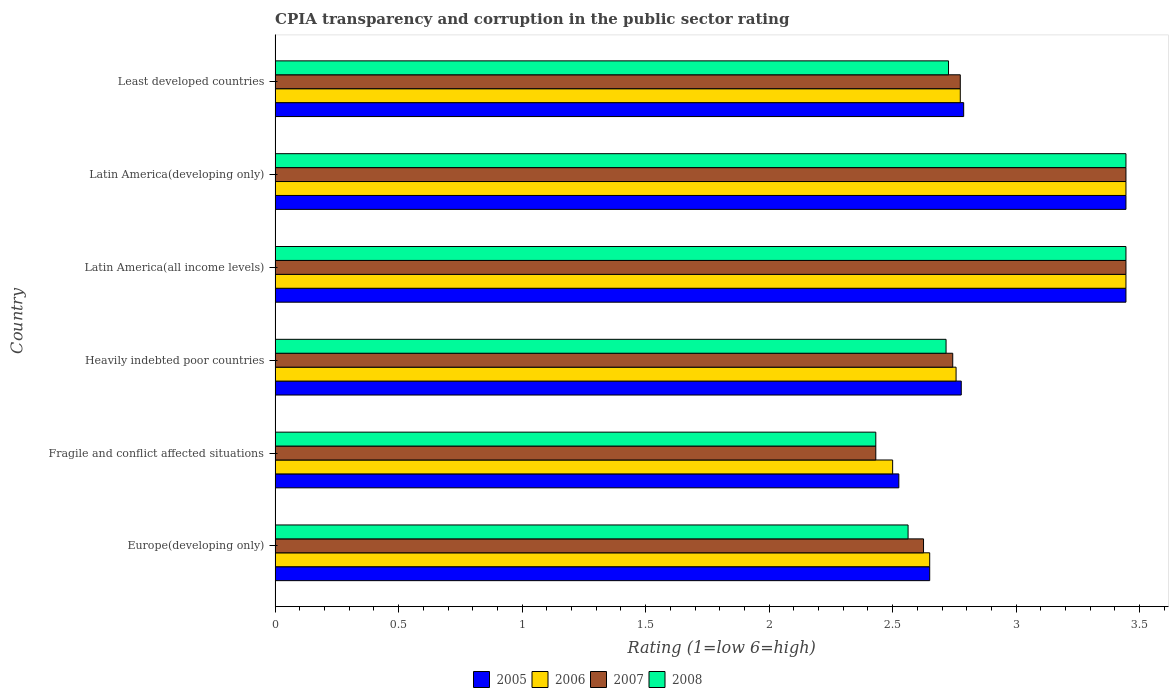How many different coloured bars are there?
Provide a short and direct response. 4. How many bars are there on the 3rd tick from the top?
Offer a terse response. 4. How many bars are there on the 2nd tick from the bottom?
Your answer should be compact. 4. What is the label of the 6th group of bars from the top?
Your answer should be compact. Europe(developing only). What is the CPIA rating in 2008 in Latin America(all income levels)?
Provide a succinct answer. 3.44. Across all countries, what is the maximum CPIA rating in 2005?
Provide a succinct answer. 3.44. Across all countries, what is the minimum CPIA rating in 2007?
Your answer should be compact. 2.43. In which country was the CPIA rating in 2006 maximum?
Your answer should be very brief. Latin America(all income levels). In which country was the CPIA rating in 2008 minimum?
Ensure brevity in your answer.  Fragile and conflict affected situations. What is the total CPIA rating in 2008 in the graph?
Give a very brief answer. 17.33. What is the difference between the CPIA rating in 2006 in Europe(developing only) and that in Heavily indebted poor countries?
Your answer should be very brief. -0.11. What is the difference between the CPIA rating in 2008 in Fragile and conflict affected situations and the CPIA rating in 2007 in Least developed countries?
Your answer should be compact. -0.34. What is the average CPIA rating in 2007 per country?
Give a very brief answer. 2.91. What is the difference between the CPIA rating in 2007 and CPIA rating in 2008 in Latin America(developing only)?
Your answer should be compact. 0. In how many countries, is the CPIA rating in 2006 greater than 1.7 ?
Ensure brevity in your answer.  6. What is the ratio of the CPIA rating in 2008 in Europe(developing only) to that in Latin America(all income levels)?
Offer a very short reply. 0.74. Is the CPIA rating in 2006 in Fragile and conflict affected situations less than that in Heavily indebted poor countries?
Your response must be concise. Yes. Is the difference between the CPIA rating in 2007 in Fragile and conflict affected situations and Latin America(developing only) greater than the difference between the CPIA rating in 2008 in Fragile and conflict affected situations and Latin America(developing only)?
Offer a very short reply. No. What is the difference between the highest and the lowest CPIA rating in 2008?
Provide a short and direct response. 1.01. Is it the case that in every country, the sum of the CPIA rating in 2008 and CPIA rating in 2006 is greater than the sum of CPIA rating in 2007 and CPIA rating in 2005?
Keep it short and to the point. No. Is it the case that in every country, the sum of the CPIA rating in 2005 and CPIA rating in 2006 is greater than the CPIA rating in 2008?
Give a very brief answer. Yes. What is the difference between two consecutive major ticks on the X-axis?
Keep it short and to the point. 0.5. Are the values on the major ticks of X-axis written in scientific E-notation?
Your response must be concise. No. Does the graph contain grids?
Keep it short and to the point. No. Where does the legend appear in the graph?
Your response must be concise. Bottom center. What is the title of the graph?
Provide a short and direct response. CPIA transparency and corruption in the public sector rating. Does "2000" appear as one of the legend labels in the graph?
Provide a succinct answer. No. What is the label or title of the X-axis?
Make the answer very short. Rating (1=low 6=high). What is the Rating (1=low 6=high) in 2005 in Europe(developing only)?
Offer a very short reply. 2.65. What is the Rating (1=low 6=high) of 2006 in Europe(developing only)?
Your answer should be very brief. 2.65. What is the Rating (1=low 6=high) of 2007 in Europe(developing only)?
Ensure brevity in your answer.  2.62. What is the Rating (1=low 6=high) of 2008 in Europe(developing only)?
Your answer should be very brief. 2.56. What is the Rating (1=low 6=high) of 2005 in Fragile and conflict affected situations?
Your answer should be very brief. 2.52. What is the Rating (1=low 6=high) in 2007 in Fragile and conflict affected situations?
Your answer should be very brief. 2.43. What is the Rating (1=low 6=high) of 2008 in Fragile and conflict affected situations?
Make the answer very short. 2.43. What is the Rating (1=low 6=high) in 2005 in Heavily indebted poor countries?
Your response must be concise. 2.78. What is the Rating (1=low 6=high) in 2006 in Heavily indebted poor countries?
Your answer should be compact. 2.76. What is the Rating (1=low 6=high) in 2007 in Heavily indebted poor countries?
Provide a succinct answer. 2.74. What is the Rating (1=low 6=high) of 2008 in Heavily indebted poor countries?
Offer a very short reply. 2.72. What is the Rating (1=low 6=high) in 2005 in Latin America(all income levels)?
Your answer should be very brief. 3.44. What is the Rating (1=low 6=high) of 2006 in Latin America(all income levels)?
Your answer should be very brief. 3.44. What is the Rating (1=low 6=high) of 2007 in Latin America(all income levels)?
Your answer should be very brief. 3.44. What is the Rating (1=low 6=high) in 2008 in Latin America(all income levels)?
Provide a short and direct response. 3.44. What is the Rating (1=low 6=high) of 2005 in Latin America(developing only)?
Provide a short and direct response. 3.44. What is the Rating (1=low 6=high) in 2006 in Latin America(developing only)?
Your answer should be compact. 3.44. What is the Rating (1=low 6=high) in 2007 in Latin America(developing only)?
Give a very brief answer. 3.44. What is the Rating (1=low 6=high) of 2008 in Latin America(developing only)?
Keep it short and to the point. 3.44. What is the Rating (1=low 6=high) in 2005 in Least developed countries?
Give a very brief answer. 2.79. What is the Rating (1=low 6=high) of 2006 in Least developed countries?
Offer a very short reply. 2.77. What is the Rating (1=low 6=high) in 2007 in Least developed countries?
Provide a short and direct response. 2.77. What is the Rating (1=low 6=high) in 2008 in Least developed countries?
Provide a succinct answer. 2.73. Across all countries, what is the maximum Rating (1=low 6=high) in 2005?
Your answer should be compact. 3.44. Across all countries, what is the maximum Rating (1=low 6=high) in 2006?
Your answer should be compact. 3.44. Across all countries, what is the maximum Rating (1=low 6=high) in 2007?
Your answer should be very brief. 3.44. Across all countries, what is the maximum Rating (1=low 6=high) in 2008?
Your response must be concise. 3.44. Across all countries, what is the minimum Rating (1=low 6=high) in 2005?
Ensure brevity in your answer.  2.52. Across all countries, what is the minimum Rating (1=low 6=high) in 2006?
Offer a terse response. 2.5. Across all countries, what is the minimum Rating (1=low 6=high) of 2007?
Your response must be concise. 2.43. Across all countries, what is the minimum Rating (1=low 6=high) of 2008?
Ensure brevity in your answer.  2.43. What is the total Rating (1=low 6=high) in 2005 in the graph?
Provide a succinct answer. 17.63. What is the total Rating (1=low 6=high) in 2006 in the graph?
Offer a very short reply. 17.57. What is the total Rating (1=low 6=high) of 2007 in the graph?
Your answer should be compact. 17.46. What is the total Rating (1=low 6=high) of 2008 in the graph?
Make the answer very short. 17.33. What is the difference between the Rating (1=low 6=high) of 2007 in Europe(developing only) and that in Fragile and conflict affected situations?
Offer a terse response. 0.19. What is the difference between the Rating (1=low 6=high) in 2008 in Europe(developing only) and that in Fragile and conflict affected situations?
Offer a terse response. 0.13. What is the difference between the Rating (1=low 6=high) in 2005 in Europe(developing only) and that in Heavily indebted poor countries?
Give a very brief answer. -0.13. What is the difference between the Rating (1=low 6=high) of 2006 in Europe(developing only) and that in Heavily indebted poor countries?
Provide a succinct answer. -0.11. What is the difference between the Rating (1=low 6=high) in 2007 in Europe(developing only) and that in Heavily indebted poor countries?
Offer a terse response. -0.12. What is the difference between the Rating (1=low 6=high) of 2008 in Europe(developing only) and that in Heavily indebted poor countries?
Keep it short and to the point. -0.15. What is the difference between the Rating (1=low 6=high) of 2005 in Europe(developing only) and that in Latin America(all income levels)?
Keep it short and to the point. -0.79. What is the difference between the Rating (1=low 6=high) of 2006 in Europe(developing only) and that in Latin America(all income levels)?
Make the answer very short. -0.79. What is the difference between the Rating (1=low 6=high) of 2007 in Europe(developing only) and that in Latin America(all income levels)?
Make the answer very short. -0.82. What is the difference between the Rating (1=low 6=high) of 2008 in Europe(developing only) and that in Latin America(all income levels)?
Ensure brevity in your answer.  -0.88. What is the difference between the Rating (1=low 6=high) of 2005 in Europe(developing only) and that in Latin America(developing only)?
Provide a succinct answer. -0.79. What is the difference between the Rating (1=low 6=high) in 2006 in Europe(developing only) and that in Latin America(developing only)?
Provide a succinct answer. -0.79. What is the difference between the Rating (1=low 6=high) of 2007 in Europe(developing only) and that in Latin America(developing only)?
Your answer should be compact. -0.82. What is the difference between the Rating (1=low 6=high) in 2008 in Europe(developing only) and that in Latin America(developing only)?
Provide a short and direct response. -0.88. What is the difference between the Rating (1=low 6=high) of 2005 in Europe(developing only) and that in Least developed countries?
Keep it short and to the point. -0.14. What is the difference between the Rating (1=low 6=high) of 2006 in Europe(developing only) and that in Least developed countries?
Provide a short and direct response. -0.12. What is the difference between the Rating (1=low 6=high) in 2007 in Europe(developing only) and that in Least developed countries?
Provide a succinct answer. -0.15. What is the difference between the Rating (1=low 6=high) in 2008 in Europe(developing only) and that in Least developed countries?
Your response must be concise. -0.16. What is the difference between the Rating (1=low 6=high) in 2005 in Fragile and conflict affected situations and that in Heavily indebted poor countries?
Give a very brief answer. -0.25. What is the difference between the Rating (1=low 6=high) in 2006 in Fragile and conflict affected situations and that in Heavily indebted poor countries?
Your answer should be compact. -0.26. What is the difference between the Rating (1=low 6=high) in 2007 in Fragile and conflict affected situations and that in Heavily indebted poor countries?
Keep it short and to the point. -0.31. What is the difference between the Rating (1=low 6=high) in 2008 in Fragile and conflict affected situations and that in Heavily indebted poor countries?
Your response must be concise. -0.28. What is the difference between the Rating (1=low 6=high) of 2005 in Fragile and conflict affected situations and that in Latin America(all income levels)?
Provide a short and direct response. -0.92. What is the difference between the Rating (1=low 6=high) in 2006 in Fragile and conflict affected situations and that in Latin America(all income levels)?
Offer a terse response. -0.94. What is the difference between the Rating (1=low 6=high) of 2007 in Fragile and conflict affected situations and that in Latin America(all income levels)?
Provide a succinct answer. -1.01. What is the difference between the Rating (1=low 6=high) of 2008 in Fragile and conflict affected situations and that in Latin America(all income levels)?
Provide a succinct answer. -1.01. What is the difference between the Rating (1=low 6=high) of 2005 in Fragile and conflict affected situations and that in Latin America(developing only)?
Your answer should be compact. -0.92. What is the difference between the Rating (1=low 6=high) in 2006 in Fragile and conflict affected situations and that in Latin America(developing only)?
Your answer should be compact. -0.94. What is the difference between the Rating (1=low 6=high) in 2007 in Fragile and conflict affected situations and that in Latin America(developing only)?
Offer a terse response. -1.01. What is the difference between the Rating (1=low 6=high) in 2008 in Fragile and conflict affected situations and that in Latin America(developing only)?
Make the answer very short. -1.01. What is the difference between the Rating (1=low 6=high) of 2005 in Fragile and conflict affected situations and that in Least developed countries?
Ensure brevity in your answer.  -0.26. What is the difference between the Rating (1=low 6=high) in 2006 in Fragile and conflict affected situations and that in Least developed countries?
Your answer should be compact. -0.27. What is the difference between the Rating (1=low 6=high) in 2007 in Fragile and conflict affected situations and that in Least developed countries?
Keep it short and to the point. -0.34. What is the difference between the Rating (1=low 6=high) of 2008 in Fragile and conflict affected situations and that in Least developed countries?
Offer a very short reply. -0.29. What is the difference between the Rating (1=low 6=high) of 2006 in Heavily indebted poor countries and that in Latin America(all income levels)?
Offer a terse response. -0.69. What is the difference between the Rating (1=low 6=high) in 2007 in Heavily indebted poor countries and that in Latin America(all income levels)?
Your response must be concise. -0.7. What is the difference between the Rating (1=low 6=high) in 2008 in Heavily indebted poor countries and that in Latin America(all income levels)?
Ensure brevity in your answer.  -0.73. What is the difference between the Rating (1=low 6=high) of 2006 in Heavily indebted poor countries and that in Latin America(developing only)?
Ensure brevity in your answer.  -0.69. What is the difference between the Rating (1=low 6=high) of 2007 in Heavily indebted poor countries and that in Latin America(developing only)?
Give a very brief answer. -0.7. What is the difference between the Rating (1=low 6=high) in 2008 in Heavily indebted poor countries and that in Latin America(developing only)?
Offer a very short reply. -0.73. What is the difference between the Rating (1=low 6=high) of 2005 in Heavily indebted poor countries and that in Least developed countries?
Make the answer very short. -0.01. What is the difference between the Rating (1=low 6=high) of 2006 in Heavily indebted poor countries and that in Least developed countries?
Ensure brevity in your answer.  -0.02. What is the difference between the Rating (1=low 6=high) in 2007 in Heavily indebted poor countries and that in Least developed countries?
Your answer should be very brief. -0.03. What is the difference between the Rating (1=low 6=high) in 2008 in Heavily indebted poor countries and that in Least developed countries?
Keep it short and to the point. -0.01. What is the difference between the Rating (1=low 6=high) in 2005 in Latin America(all income levels) and that in Latin America(developing only)?
Your answer should be compact. 0. What is the difference between the Rating (1=low 6=high) of 2006 in Latin America(all income levels) and that in Latin America(developing only)?
Keep it short and to the point. 0. What is the difference between the Rating (1=low 6=high) of 2007 in Latin America(all income levels) and that in Latin America(developing only)?
Your answer should be very brief. 0. What is the difference between the Rating (1=low 6=high) in 2008 in Latin America(all income levels) and that in Latin America(developing only)?
Give a very brief answer. 0. What is the difference between the Rating (1=low 6=high) of 2005 in Latin America(all income levels) and that in Least developed countries?
Ensure brevity in your answer.  0.66. What is the difference between the Rating (1=low 6=high) in 2006 in Latin America(all income levels) and that in Least developed countries?
Offer a terse response. 0.67. What is the difference between the Rating (1=low 6=high) in 2007 in Latin America(all income levels) and that in Least developed countries?
Provide a succinct answer. 0.67. What is the difference between the Rating (1=low 6=high) of 2008 in Latin America(all income levels) and that in Least developed countries?
Ensure brevity in your answer.  0.72. What is the difference between the Rating (1=low 6=high) of 2005 in Latin America(developing only) and that in Least developed countries?
Give a very brief answer. 0.66. What is the difference between the Rating (1=low 6=high) in 2006 in Latin America(developing only) and that in Least developed countries?
Offer a very short reply. 0.67. What is the difference between the Rating (1=low 6=high) in 2007 in Latin America(developing only) and that in Least developed countries?
Make the answer very short. 0.67. What is the difference between the Rating (1=low 6=high) of 2008 in Latin America(developing only) and that in Least developed countries?
Give a very brief answer. 0.72. What is the difference between the Rating (1=low 6=high) in 2005 in Europe(developing only) and the Rating (1=low 6=high) in 2007 in Fragile and conflict affected situations?
Give a very brief answer. 0.22. What is the difference between the Rating (1=low 6=high) in 2005 in Europe(developing only) and the Rating (1=low 6=high) in 2008 in Fragile and conflict affected situations?
Provide a short and direct response. 0.22. What is the difference between the Rating (1=low 6=high) of 2006 in Europe(developing only) and the Rating (1=low 6=high) of 2007 in Fragile and conflict affected situations?
Make the answer very short. 0.22. What is the difference between the Rating (1=low 6=high) in 2006 in Europe(developing only) and the Rating (1=low 6=high) in 2008 in Fragile and conflict affected situations?
Your answer should be compact. 0.22. What is the difference between the Rating (1=low 6=high) of 2007 in Europe(developing only) and the Rating (1=low 6=high) of 2008 in Fragile and conflict affected situations?
Provide a short and direct response. 0.19. What is the difference between the Rating (1=low 6=high) of 2005 in Europe(developing only) and the Rating (1=low 6=high) of 2006 in Heavily indebted poor countries?
Make the answer very short. -0.11. What is the difference between the Rating (1=low 6=high) in 2005 in Europe(developing only) and the Rating (1=low 6=high) in 2007 in Heavily indebted poor countries?
Offer a very short reply. -0.09. What is the difference between the Rating (1=low 6=high) in 2005 in Europe(developing only) and the Rating (1=low 6=high) in 2008 in Heavily indebted poor countries?
Your answer should be very brief. -0.07. What is the difference between the Rating (1=low 6=high) in 2006 in Europe(developing only) and the Rating (1=low 6=high) in 2007 in Heavily indebted poor countries?
Ensure brevity in your answer.  -0.09. What is the difference between the Rating (1=low 6=high) of 2006 in Europe(developing only) and the Rating (1=low 6=high) of 2008 in Heavily indebted poor countries?
Offer a terse response. -0.07. What is the difference between the Rating (1=low 6=high) of 2007 in Europe(developing only) and the Rating (1=low 6=high) of 2008 in Heavily indebted poor countries?
Keep it short and to the point. -0.09. What is the difference between the Rating (1=low 6=high) in 2005 in Europe(developing only) and the Rating (1=low 6=high) in 2006 in Latin America(all income levels)?
Offer a terse response. -0.79. What is the difference between the Rating (1=low 6=high) of 2005 in Europe(developing only) and the Rating (1=low 6=high) of 2007 in Latin America(all income levels)?
Offer a very short reply. -0.79. What is the difference between the Rating (1=low 6=high) of 2005 in Europe(developing only) and the Rating (1=low 6=high) of 2008 in Latin America(all income levels)?
Your response must be concise. -0.79. What is the difference between the Rating (1=low 6=high) in 2006 in Europe(developing only) and the Rating (1=low 6=high) in 2007 in Latin America(all income levels)?
Provide a short and direct response. -0.79. What is the difference between the Rating (1=low 6=high) of 2006 in Europe(developing only) and the Rating (1=low 6=high) of 2008 in Latin America(all income levels)?
Offer a very short reply. -0.79. What is the difference between the Rating (1=low 6=high) of 2007 in Europe(developing only) and the Rating (1=low 6=high) of 2008 in Latin America(all income levels)?
Provide a succinct answer. -0.82. What is the difference between the Rating (1=low 6=high) of 2005 in Europe(developing only) and the Rating (1=low 6=high) of 2006 in Latin America(developing only)?
Provide a succinct answer. -0.79. What is the difference between the Rating (1=low 6=high) of 2005 in Europe(developing only) and the Rating (1=low 6=high) of 2007 in Latin America(developing only)?
Offer a terse response. -0.79. What is the difference between the Rating (1=low 6=high) of 2005 in Europe(developing only) and the Rating (1=low 6=high) of 2008 in Latin America(developing only)?
Your response must be concise. -0.79. What is the difference between the Rating (1=low 6=high) of 2006 in Europe(developing only) and the Rating (1=low 6=high) of 2007 in Latin America(developing only)?
Offer a terse response. -0.79. What is the difference between the Rating (1=low 6=high) of 2006 in Europe(developing only) and the Rating (1=low 6=high) of 2008 in Latin America(developing only)?
Your answer should be very brief. -0.79. What is the difference between the Rating (1=low 6=high) in 2007 in Europe(developing only) and the Rating (1=low 6=high) in 2008 in Latin America(developing only)?
Make the answer very short. -0.82. What is the difference between the Rating (1=low 6=high) in 2005 in Europe(developing only) and the Rating (1=low 6=high) in 2006 in Least developed countries?
Offer a very short reply. -0.12. What is the difference between the Rating (1=low 6=high) of 2005 in Europe(developing only) and the Rating (1=low 6=high) of 2007 in Least developed countries?
Provide a succinct answer. -0.12. What is the difference between the Rating (1=low 6=high) of 2005 in Europe(developing only) and the Rating (1=low 6=high) of 2008 in Least developed countries?
Make the answer very short. -0.08. What is the difference between the Rating (1=low 6=high) in 2006 in Europe(developing only) and the Rating (1=low 6=high) in 2007 in Least developed countries?
Your response must be concise. -0.12. What is the difference between the Rating (1=low 6=high) in 2006 in Europe(developing only) and the Rating (1=low 6=high) in 2008 in Least developed countries?
Your answer should be compact. -0.08. What is the difference between the Rating (1=low 6=high) of 2007 in Europe(developing only) and the Rating (1=low 6=high) of 2008 in Least developed countries?
Give a very brief answer. -0.1. What is the difference between the Rating (1=low 6=high) of 2005 in Fragile and conflict affected situations and the Rating (1=low 6=high) of 2006 in Heavily indebted poor countries?
Your response must be concise. -0.23. What is the difference between the Rating (1=low 6=high) of 2005 in Fragile and conflict affected situations and the Rating (1=low 6=high) of 2007 in Heavily indebted poor countries?
Ensure brevity in your answer.  -0.22. What is the difference between the Rating (1=low 6=high) in 2005 in Fragile and conflict affected situations and the Rating (1=low 6=high) in 2008 in Heavily indebted poor countries?
Make the answer very short. -0.19. What is the difference between the Rating (1=low 6=high) of 2006 in Fragile and conflict affected situations and the Rating (1=low 6=high) of 2007 in Heavily indebted poor countries?
Your answer should be compact. -0.24. What is the difference between the Rating (1=low 6=high) of 2006 in Fragile and conflict affected situations and the Rating (1=low 6=high) of 2008 in Heavily indebted poor countries?
Offer a terse response. -0.22. What is the difference between the Rating (1=low 6=high) of 2007 in Fragile and conflict affected situations and the Rating (1=low 6=high) of 2008 in Heavily indebted poor countries?
Offer a terse response. -0.28. What is the difference between the Rating (1=low 6=high) of 2005 in Fragile and conflict affected situations and the Rating (1=low 6=high) of 2006 in Latin America(all income levels)?
Keep it short and to the point. -0.92. What is the difference between the Rating (1=low 6=high) of 2005 in Fragile and conflict affected situations and the Rating (1=low 6=high) of 2007 in Latin America(all income levels)?
Your answer should be compact. -0.92. What is the difference between the Rating (1=low 6=high) in 2005 in Fragile and conflict affected situations and the Rating (1=low 6=high) in 2008 in Latin America(all income levels)?
Offer a terse response. -0.92. What is the difference between the Rating (1=low 6=high) in 2006 in Fragile and conflict affected situations and the Rating (1=low 6=high) in 2007 in Latin America(all income levels)?
Provide a short and direct response. -0.94. What is the difference between the Rating (1=low 6=high) in 2006 in Fragile and conflict affected situations and the Rating (1=low 6=high) in 2008 in Latin America(all income levels)?
Ensure brevity in your answer.  -0.94. What is the difference between the Rating (1=low 6=high) of 2007 in Fragile and conflict affected situations and the Rating (1=low 6=high) of 2008 in Latin America(all income levels)?
Ensure brevity in your answer.  -1.01. What is the difference between the Rating (1=low 6=high) of 2005 in Fragile and conflict affected situations and the Rating (1=low 6=high) of 2006 in Latin America(developing only)?
Keep it short and to the point. -0.92. What is the difference between the Rating (1=low 6=high) of 2005 in Fragile and conflict affected situations and the Rating (1=low 6=high) of 2007 in Latin America(developing only)?
Ensure brevity in your answer.  -0.92. What is the difference between the Rating (1=low 6=high) of 2005 in Fragile and conflict affected situations and the Rating (1=low 6=high) of 2008 in Latin America(developing only)?
Offer a very short reply. -0.92. What is the difference between the Rating (1=low 6=high) of 2006 in Fragile and conflict affected situations and the Rating (1=low 6=high) of 2007 in Latin America(developing only)?
Your answer should be compact. -0.94. What is the difference between the Rating (1=low 6=high) in 2006 in Fragile and conflict affected situations and the Rating (1=low 6=high) in 2008 in Latin America(developing only)?
Your answer should be compact. -0.94. What is the difference between the Rating (1=low 6=high) of 2007 in Fragile and conflict affected situations and the Rating (1=low 6=high) of 2008 in Latin America(developing only)?
Your response must be concise. -1.01. What is the difference between the Rating (1=low 6=high) in 2005 in Fragile and conflict affected situations and the Rating (1=low 6=high) in 2006 in Least developed countries?
Provide a succinct answer. -0.25. What is the difference between the Rating (1=low 6=high) in 2005 in Fragile and conflict affected situations and the Rating (1=low 6=high) in 2007 in Least developed countries?
Make the answer very short. -0.25. What is the difference between the Rating (1=low 6=high) of 2005 in Fragile and conflict affected situations and the Rating (1=low 6=high) of 2008 in Least developed countries?
Provide a short and direct response. -0.2. What is the difference between the Rating (1=low 6=high) in 2006 in Fragile and conflict affected situations and the Rating (1=low 6=high) in 2007 in Least developed countries?
Offer a terse response. -0.27. What is the difference between the Rating (1=low 6=high) of 2006 in Fragile and conflict affected situations and the Rating (1=low 6=high) of 2008 in Least developed countries?
Offer a terse response. -0.23. What is the difference between the Rating (1=low 6=high) in 2007 in Fragile and conflict affected situations and the Rating (1=low 6=high) in 2008 in Least developed countries?
Offer a very short reply. -0.29. What is the difference between the Rating (1=low 6=high) in 2005 in Heavily indebted poor countries and the Rating (1=low 6=high) in 2006 in Latin America(all income levels)?
Offer a very short reply. -0.67. What is the difference between the Rating (1=low 6=high) in 2005 in Heavily indebted poor countries and the Rating (1=low 6=high) in 2008 in Latin America(all income levels)?
Your answer should be compact. -0.67. What is the difference between the Rating (1=low 6=high) in 2006 in Heavily indebted poor countries and the Rating (1=low 6=high) in 2007 in Latin America(all income levels)?
Give a very brief answer. -0.69. What is the difference between the Rating (1=low 6=high) in 2006 in Heavily indebted poor countries and the Rating (1=low 6=high) in 2008 in Latin America(all income levels)?
Ensure brevity in your answer.  -0.69. What is the difference between the Rating (1=low 6=high) in 2007 in Heavily indebted poor countries and the Rating (1=low 6=high) in 2008 in Latin America(all income levels)?
Keep it short and to the point. -0.7. What is the difference between the Rating (1=low 6=high) of 2005 in Heavily indebted poor countries and the Rating (1=low 6=high) of 2006 in Latin America(developing only)?
Your response must be concise. -0.67. What is the difference between the Rating (1=low 6=high) in 2006 in Heavily indebted poor countries and the Rating (1=low 6=high) in 2007 in Latin America(developing only)?
Make the answer very short. -0.69. What is the difference between the Rating (1=low 6=high) of 2006 in Heavily indebted poor countries and the Rating (1=low 6=high) of 2008 in Latin America(developing only)?
Ensure brevity in your answer.  -0.69. What is the difference between the Rating (1=low 6=high) of 2007 in Heavily indebted poor countries and the Rating (1=low 6=high) of 2008 in Latin America(developing only)?
Provide a short and direct response. -0.7. What is the difference between the Rating (1=low 6=high) in 2005 in Heavily indebted poor countries and the Rating (1=low 6=high) in 2006 in Least developed countries?
Your response must be concise. 0. What is the difference between the Rating (1=low 6=high) of 2005 in Heavily indebted poor countries and the Rating (1=low 6=high) of 2007 in Least developed countries?
Keep it short and to the point. 0. What is the difference between the Rating (1=low 6=high) in 2005 in Heavily indebted poor countries and the Rating (1=low 6=high) in 2008 in Least developed countries?
Keep it short and to the point. 0.05. What is the difference between the Rating (1=low 6=high) in 2006 in Heavily indebted poor countries and the Rating (1=low 6=high) in 2007 in Least developed countries?
Ensure brevity in your answer.  -0.02. What is the difference between the Rating (1=low 6=high) of 2006 in Heavily indebted poor countries and the Rating (1=low 6=high) of 2008 in Least developed countries?
Provide a short and direct response. 0.03. What is the difference between the Rating (1=low 6=high) in 2007 in Heavily indebted poor countries and the Rating (1=low 6=high) in 2008 in Least developed countries?
Give a very brief answer. 0.02. What is the difference between the Rating (1=low 6=high) of 2005 in Latin America(all income levels) and the Rating (1=low 6=high) of 2006 in Latin America(developing only)?
Offer a very short reply. 0. What is the difference between the Rating (1=low 6=high) of 2005 in Latin America(all income levels) and the Rating (1=low 6=high) of 2007 in Latin America(developing only)?
Your response must be concise. 0. What is the difference between the Rating (1=low 6=high) of 2006 in Latin America(all income levels) and the Rating (1=low 6=high) of 2008 in Latin America(developing only)?
Provide a short and direct response. 0. What is the difference between the Rating (1=low 6=high) of 2007 in Latin America(all income levels) and the Rating (1=low 6=high) of 2008 in Latin America(developing only)?
Offer a terse response. 0. What is the difference between the Rating (1=low 6=high) of 2005 in Latin America(all income levels) and the Rating (1=low 6=high) of 2006 in Least developed countries?
Make the answer very short. 0.67. What is the difference between the Rating (1=low 6=high) in 2005 in Latin America(all income levels) and the Rating (1=low 6=high) in 2007 in Least developed countries?
Offer a very short reply. 0.67. What is the difference between the Rating (1=low 6=high) in 2005 in Latin America(all income levels) and the Rating (1=low 6=high) in 2008 in Least developed countries?
Give a very brief answer. 0.72. What is the difference between the Rating (1=low 6=high) of 2006 in Latin America(all income levels) and the Rating (1=low 6=high) of 2007 in Least developed countries?
Ensure brevity in your answer.  0.67. What is the difference between the Rating (1=low 6=high) of 2006 in Latin America(all income levels) and the Rating (1=low 6=high) of 2008 in Least developed countries?
Provide a short and direct response. 0.72. What is the difference between the Rating (1=low 6=high) of 2007 in Latin America(all income levels) and the Rating (1=low 6=high) of 2008 in Least developed countries?
Your response must be concise. 0.72. What is the difference between the Rating (1=low 6=high) of 2005 in Latin America(developing only) and the Rating (1=low 6=high) of 2006 in Least developed countries?
Provide a succinct answer. 0.67. What is the difference between the Rating (1=low 6=high) in 2005 in Latin America(developing only) and the Rating (1=low 6=high) in 2007 in Least developed countries?
Provide a short and direct response. 0.67. What is the difference between the Rating (1=low 6=high) in 2005 in Latin America(developing only) and the Rating (1=low 6=high) in 2008 in Least developed countries?
Provide a succinct answer. 0.72. What is the difference between the Rating (1=low 6=high) of 2006 in Latin America(developing only) and the Rating (1=low 6=high) of 2007 in Least developed countries?
Give a very brief answer. 0.67. What is the difference between the Rating (1=low 6=high) of 2006 in Latin America(developing only) and the Rating (1=low 6=high) of 2008 in Least developed countries?
Your answer should be compact. 0.72. What is the difference between the Rating (1=low 6=high) of 2007 in Latin America(developing only) and the Rating (1=low 6=high) of 2008 in Least developed countries?
Your response must be concise. 0.72. What is the average Rating (1=low 6=high) in 2005 per country?
Your response must be concise. 2.94. What is the average Rating (1=low 6=high) of 2006 per country?
Keep it short and to the point. 2.93. What is the average Rating (1=low 6=high) of 2007 per country?
Ensure brevity in your answer.  2.91. What is the average Rating (1=low 6=high) of 2008 per country?
Provide a short and direct response. 2.89. What is the difference between the Rating (1=low 6=high) in 2005 and Rating (1=low 6=high) in 2006 in Europe(developing only)?
Your answer should be compact. 0. What is the difference between the Rating (1=low 6=high) in 2005 and Rating (1=low 6=high) in 2007 in Europe(developing only)?
Your answer should be very brief. 0.03. What is the difference between the Rating (1=low 6=high) of 2005 and Rating (1=low 6=high) of 2008 in Europe(developing only)?
Offer a very short reply. 0.09. What is the difference between the Rating (1=low 6=high) in 2006 and Rating (1=low 6=high) in 2007 in Europe(developing only)?
Give a very brief answer. 0.03. What is the difference between the Rating (1=low 6=high) of 2006 and Rating (1=low 6=high) of 2008 in Europe(developing only)?
Keep it short and to the point. 0.09. What is the difference between the Rating (1=low 6=high) in 2007 and Rating (1=low 6=high) in 2008 in Europe(developing only)?
Offer a terse response. 0.06. What is the difference between the Rating (1=low 6=high) in 2005 and Rating (1=low 6=high) in 2006 in Fragile and conflict affected situations?
Offer a very short reply. 0.03. What is the difference between the Rating (1=low 6=high) of 2005 and Rating (1=low 6=high) of 2007 in Fragile and conflict affected situations?
Your response must be concise. 0.09. What is the difference between the Rating (1=low 6=high) of 2005 and Rating (1=low 6=high) of 2008 in Fragile and conflict affected situations?
Give a very brief answer. 0.09. What is the difference between the Rating (1=low 6=high) of 2006 and Rating (1=low 6=high) of 2007 in Fragile and conflict affected situations?
Keep it short and to the point. 0.07. What is the difference between the Rating (1=low 6=high) of 2006 and Rating (1=low 6=high) of 2008 in Fragile and conflict affected situations?
Provide a succinct answer. 0.07. What is the difference between the Rating (1=low 6=high) of 2005 and Rating (1=low 6=high) of 2006 in Heavily indebted poor countries?
Provide a succinct answer. 0.02. What is the difference between the Rating (1=low 6=high) of 2005 and Rating (1=low 6=high) of 2007 in Heavily indebted poor countries?
Keep it short and to the point. 0.03. What is the difference between the Rating (1=low 6=high) of 2005 and Rating (1=low 6=high) of 2008 in Heavily indebted poor countries?
Your answer should be compact. 0.06. What is the difference between the Rating (1=low 6=high) in 2006 and Rating (1=low 6=high) in 2007 in Heavily indebted poor countries?
Provide a short and direct response. 0.01. What is the difference between the Rating (1=low 6=high) of 2006 and Rating (1=low 6=high) of 2008 in Heavily indebted poor countries?
Provide a short and direct response. 0.04. What is the difference between the Rating (1=low 6=high) of 2007 and Rating (1=low 6=high) of 2008 in Heavily indebted poor countries?
Provide a succinct answer. 0.03. What is the difference between the Rating (1=low 6=high) of 2006 and Rating (1=low 6=high) of 2007 in Latin America(all income levels)?
Provide a succinct answer. 0. What is the difference between the Rating (1=low 6=high) of 2006 and Rating (1=low 6=high) of 2008 in Latin America(all income levels)?
Provide a succinct answer. 0. What is the difference between the Rating (1=low 6=high) in 2007 and Rating (1=low 6=high) in 2008 in Latin America(all income levels)?
Give a very brief answer. 0. What is the difference between the Rating (1=low 6=high) of 2005 and Rating (1=low 6=high) of 2008 in Latin America(developing only)?
Keep it short and to the point. 0. What is the difference between the Rating (1=low 6=high) of 2006 and Rating (1=low 6=high) of 2007 in Latin America(developing only)?
Your response must be concise. 0. What is the difference between the Rating (1=low 6=high) of 2006 and Rating (1=low 6=high) of 2008 in Latin America(developing only)?
Ensure brevity in your answer.  0. What is the difference between the Rating (1=low 6=high) in 2007 and Rating (1=low 6=high) in 2008 in Latin America(developing only)?
Your response must be concise. 0. What is the difference between the Rating (1=low 6=high) in 2005 and Rating (1=low 6=high) in 2006 in Least developed countries?
Provide a succinct answer. 0.01. What is the difference between the Rating (1=low 6=high) in 2005 and Rating (1=low 6=high) in 2007 in Least developed countries?
Provide a succinct answer. 0.01. What is the difference between the Rating (1=low 6=high) in 2005 and Rating (1=low 6=high) in 2008 in Least developed countries?
Give a very brief answer. 0.06. What is the difference between the Rating (1=low 6=high) in 2006 and Rating (1=low 6=high) in 2008 in Least developed countries?
Ensure brevity in your answer.  0.05. What is the difference between the Rating (1=low 6=high) in 2007 and Rating (1=low 6=high) in 2008 in Least developed countries?
Make the answer very short. 0.05. What is the ratio of the Rating (1=low 6=high) in 2005 in Europe(developing only) to that in Fragile and conflict affected situations?
Provide a succinct answer. 1.05. What is the ratio of the Rating (1=low 6=high) in 2006 in Europe(developing only) to that in Fragile and conflict affected situations?
Give a very brief answer. 1.06. What is the ratio of the Rating (1=low 6=high) in 2007 in Europe(developing only) to that in Fragile and conflict affected situations?
Offer a terse response. 1.08. What is the ratio of the Rating (1=low 6=high) in 2008 in Europe(developing only) to that in Fragile and conflict affected situations?
Your answer should be very brief. 1.05. What is the ratio of the Rating (1=low 6=high) of 2005 in Europe(developing only) to that in Heavily indebted poor countries?
Offer a very short reply. 0.95. What is the ratio of the Rating (1=low 6=high) of 2006 in Europe(developing only) to that in Heavily indebted poor countries?
Make the answer very short. 0.96. What is the ratio of the Rating (1=low 6=high) in 2007 in Europe(developing only) to that in Heavily indebted poor countries?
Your answer should be compact. 0.96. What is the ratio of the Rating (1=low 6=high) in 2008 in Europe(developing only) to that in Heavily indebted poor countries?
Give a very brief answer. 0.94. What is the ratio of the Rating (1=low 6=high) of 2005 in Europe(developing only) to that in Latin America(all income levels)?
Make the answer very short. 0.77. What is the ratio of the Rating (1=low 6=high) of 2006 in Europe(developing only) to that in Latin America(all income levels)?
Ensure brevity in your answer.  0.77. What is the ratio of the Rating (1=low 6=high) of 2007 in Europe(developing only) to that in Latin America(all income levels)?
Make the answer very short. 0.76. What is the ratio of the Rating (1=low 6=high) in 2008 in Europe(developing only) to that in Latin America(all income levels)?
Your answer should be very brief. 0.74. What is the ratio of the Rating (1=low 6=high) of 2005 in Europe(developing only) to that in Latin America(developing only)?
Your answer should be very brief. 0.77. What is the ratio of the Rating (1=low 6=high) of 2006 in Europe(developing only) to that in Latin America(developing only)?
Your response must be concise. 0.77. What is the ratio of the Rating (1=low 6=high) in 2007 in Europe(developing only) to that in Latin America(developing only)?
Provide a short and direct response. 0.76. What is the ratio of the Rating (1=low 6=high) in 2008 in Europe(developing only) to that in Latin America(developing only)?
Ensure brevity in your answer.  0.74. What is the ratio of the Rating (1=low 6=high) of 2005 in Europe(developing only) to that in Least developed countries?
Keep it short and to the point. 0.95. What is the ratio of the Rating (1=low 6=high) in 2006 in Europe(developing only) to that in Least developed countries?
Provide a succinct answer. 0.96. What is the ratio of the Rating (1=low 6=high) of 2007 in Europe(developing only) to that in Least developed countries?
Offer a terse response. 0.95. What is the ratio of the Rating (1=low 6=high) of 2008 in Europe(developing only) to that in Least developed countries?
Your response must be concise. 0.94. What is the ratio of the Rating (1=low 6=high) of 2005 in Fragile and conflict affected situations to that in Heavily indebted poor countries?
Make the answer very short. 0.91. What is the ratio of the Rating (1=low 6=high) in 2006 in Fragile and conflict affected situations to that in Heavily indebted poor countries?
Offer a terse response. 0.91. What is the ratio of the Rating (1=low 6=high) in 2007 in Fragile and conflict affected situations to that in Heavily indebted poor countries?
Provide a succinct answer. 0.89. What is the ratio of the Rating (1=low 6=high) in 2008 in Fragile and conflict affected situations to that in Heavily indebted poor countries?
Make the answer very short. 0.9. What is the ratio of the Rating (1=low 6=high) of 2005 in Fragile and conflict affected situations to that in Latin America(all income levels)?
Ensure brevity in your answer.  0.73. What is the ratio of the Rating (1=low 6=high) in 2006 in Fragile and conflict affected situations to that in Latin America(all income levels)?
Offer a terse response. 0.73. What is the ratio of the Rating (1=low 6=high) in 2007 in Fragile and conflict affected situations to that in Latin America(all income levels)?
Make the answer very short. 0.71. What is the ratio of the Rating (1=low 6=high) of 2008 in Fragile and conflict affected situations to that in Latin America(all income levels)?
Give a very brief answer. 0.71. What is the ratio of the Rating (1=low 6=high) of 2005 in Fragile and conflict affected situations to that in Latin America(developing only)?
Offer a very short reply. 0.73. What is the ratio of the Rating (1=low 6=high) of 2006 in Fragile and conflict affected situations to that in Latin America(developing only)?
Keep it short and to the point. 0.73. What is the ratio of the Rating (1=low 6=high) of 2007 in Fragile and conflict affected situations to that in Latin America(developing only)?
Your answer should be compact. 0.71. What is the ratio of the Rating (1=low 6=high) in 2008 in Fragile and conflict affected situations to that in Latin America(developing only)?
Offer a very short reply. 0.71. What is the ratio of the Rating (1=low 6=high) in 2005 in Fragile and conflict affected situations to that in Least developed countries?
Your answer should be compact. 0.91. What is the ratio of the Rating (1=low 6=high) of 2006 in Fragile and conflict affected situations to that in Least developed countries?
Offer a terse response. 0.9. What is the ratio of the Rating (1=low 6=high) of 2007 in Fragile and conflict affected situations to that in Least developed countries?
Provide a succinct answer. 0.88. What is the ratio of the Rating (1=low 6=high) of 2008 in Fragile and conflict affected situations to that in Least developed countries?
Your answer should be compact. 0.89. What is the ratio of the Rating (1=low 6=high) in 2005 in Heavily indebted poor countries to that in Latin America(all income levels)?
Provide a short and direct response. 0.81. What is the ratio of the Rating (1=low 6=high) of 2006 in Heavily indebted poor countries to that in Latin America(all income levels)?
Make the answer very short. 0.8. What is the ratio of the Rating (1=low 6=high) in 2007 in Heavily indebted poor countries to that in Latin America(all income levels)?
Your answer should be very brief. 0.8. What is the ratio of the Rating (1=low 6=high) of 2008 in Heavily indebted poor countries to that in Latin America(all income levels)?
Offer a terse response. 0.79. What is the ratio of the Rating (1=low 6=high) in 2005 in Heavily indebted poor countries to that in Latin America(developing only)?
Give a very brief answer. 0.81. What is the ratio of the Rating (1=low 6=high) of 2006 in Heavily indebted poor countries to that in Latin America(developing only)?
Keep it short and to the point. 0.8. What is the ratio of the Rating (1=low 6=high) in 2007 in Heavily indebted poor countries to that in Latin America(developing only)?
Make the answer very short. 0.8. What is the ratio of the Rating (1=low 6=high) of 2008 in Heavily indebted poor countries to that in Latin America(developing only)?
Provide a short and direct response. 0.79. What is the ratio of the Rating (1=low 6=high) in 2006 in Heavily indebted poor countries to that in Least developed countries?
Offer a terse response. 0.99. What is the ratio of the Rating (1=low 6=high) of 2007 in Heavily indebted poor countries to that in Least developed countries?
Give a very brief answer. 0.99. What is the ratio of the Rating (1=low 6=high) of 2005 in Latin America(all income levels) to that in Latin America(developing only)?
Your answer should be compact. 1. What is the ratio of the Rating (1=low 6=high) in 2007 in Latin America(all income levels) to that in Latin America(developing only)?
Offer a very short reply. 1. What is the ratio of the Rating (1=low 6=high) in 2008 in Latin America(all income levels) to that in Latin America(developing only)?
Provide a short and direct response. 1. What is the ratio of the Rating (1=low 6=high) of 2005 in Latin America(all income levels) to that in Least developed countries?
Make the answer very short. 1.24. What is the ratio of the Rating (1=low 6=high) in 2006 in Latin America(all income levels) to that in Least developed countries?
Your answer should be compact. 1.24. What is the ratio of the Rating (1=low 6=high) in 2007 in Latin America(all income levels) to that in Least developed countries?
Keep it short and to the point. 1.24. What is the ratio of the Rating (1=low 6=high) of 2008 in Latin America(all income levels) to that in Least developed countries?
Your answer should be very brief. 1.26. What is the ratio of the Rating (1=low 6=high) of 2005 in Latin America(developing only) to that in Least developed countries?
Give a very brief answer. 1.24. What is the ratio of the Rating (1=low 6=high) in 2006 in Latin America(developing only) to that in Least developed countries?
Your response must be concise. 1.24. What is the ratio of the Rating (1=low 6=high) in 2007 in Latin America(developing only) to that in Least developed countries?
Give a very brief answer. 1.24. What is the ratio of the Rating (1=low 6=high) of 2008 in Latin America(developing only) to that in Least developed countries?
Provide a short and direct response. 1.26. What is the difference between the highest and the second highest Rating (1=low 6=high) of 2005?
Your answer should be very brief. 0. What is the difference between the highest and the second highest Rating (1=low 6=high) in 2007?
Make the answer very short. 0. What is the difference between the highest and the lowest Rating (1=low 6=high) in 2005?
Make the answer very short. 0.92. What is the difference between the highest and the lowest Rating (1=low 6=high) of 2007?
Make the answer very short. 1.01. What is the difference between the highest and the lowest Rating (1=low 6=high) in 2008?
Keep it short and to the point. 1.01. 